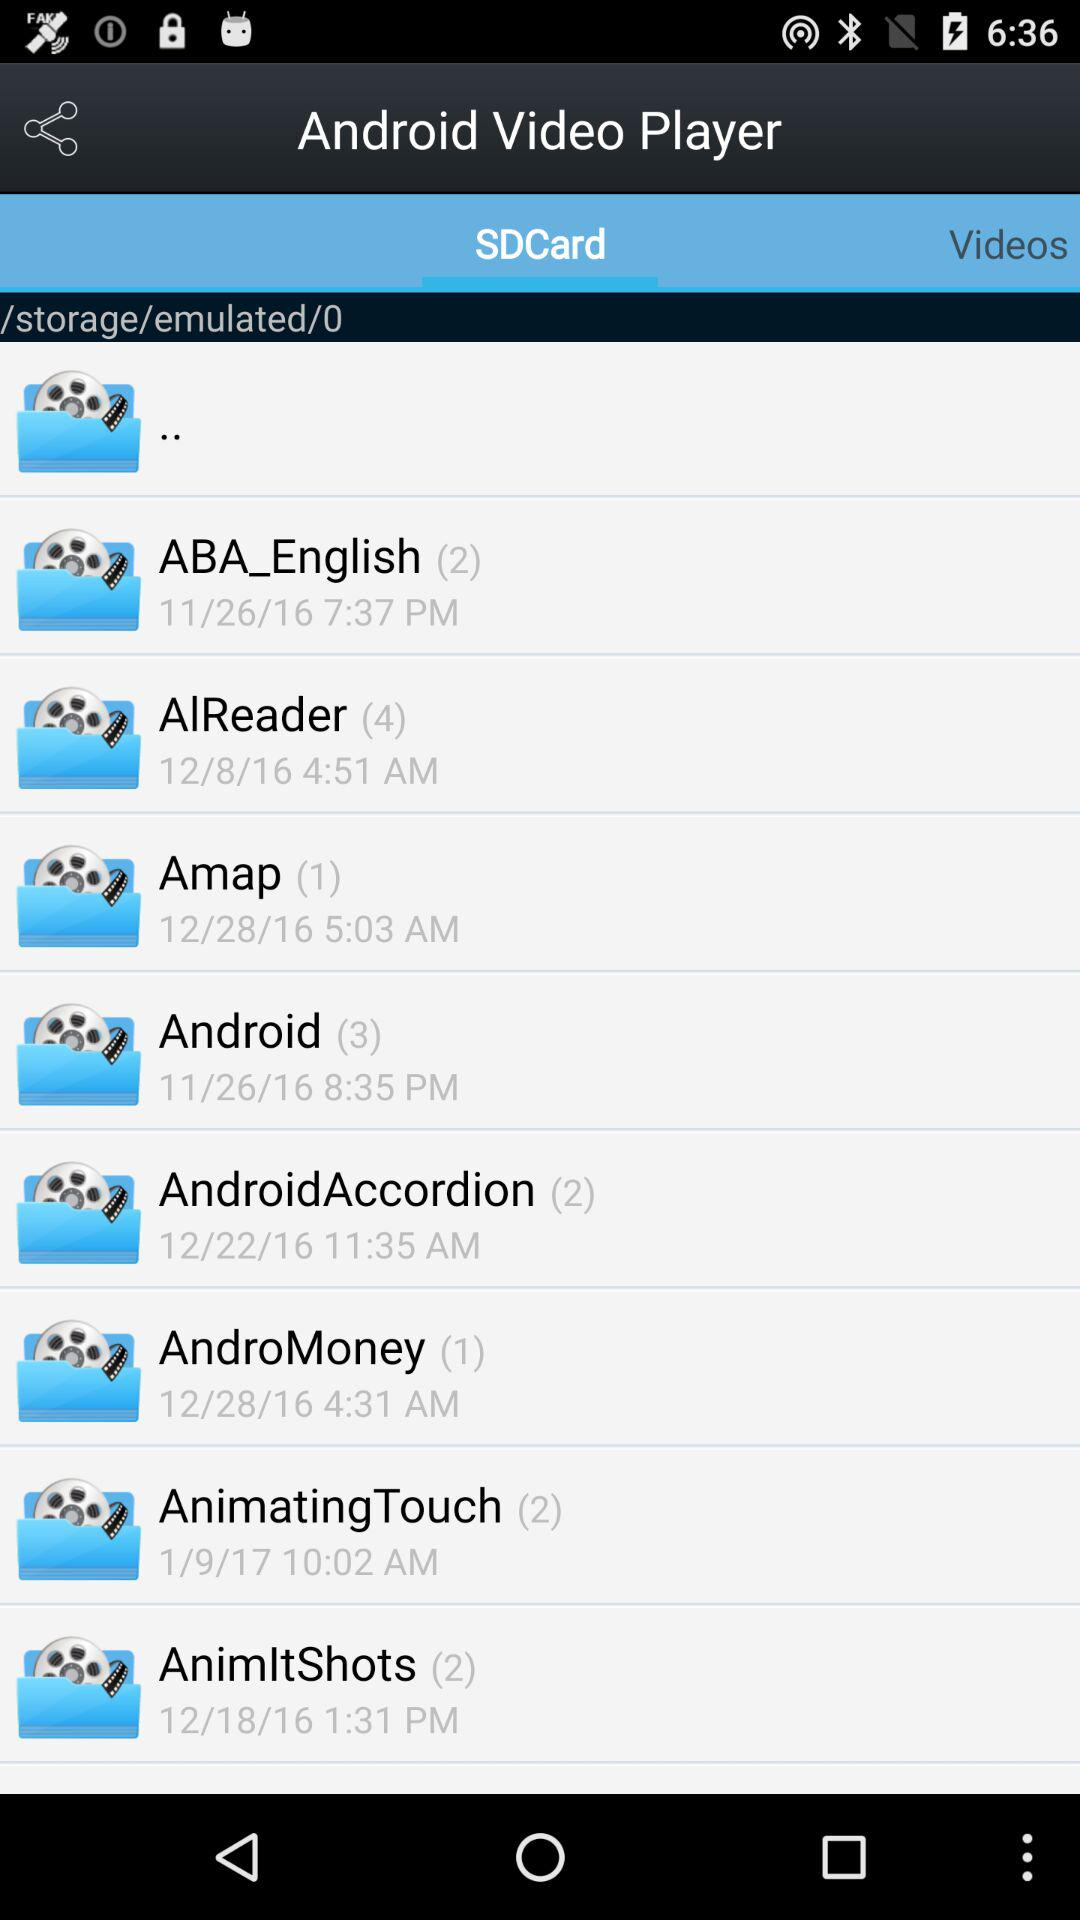Which folder was created on 1/19/17? The folder created on 1/19/17 was "AnimatingTouch". 